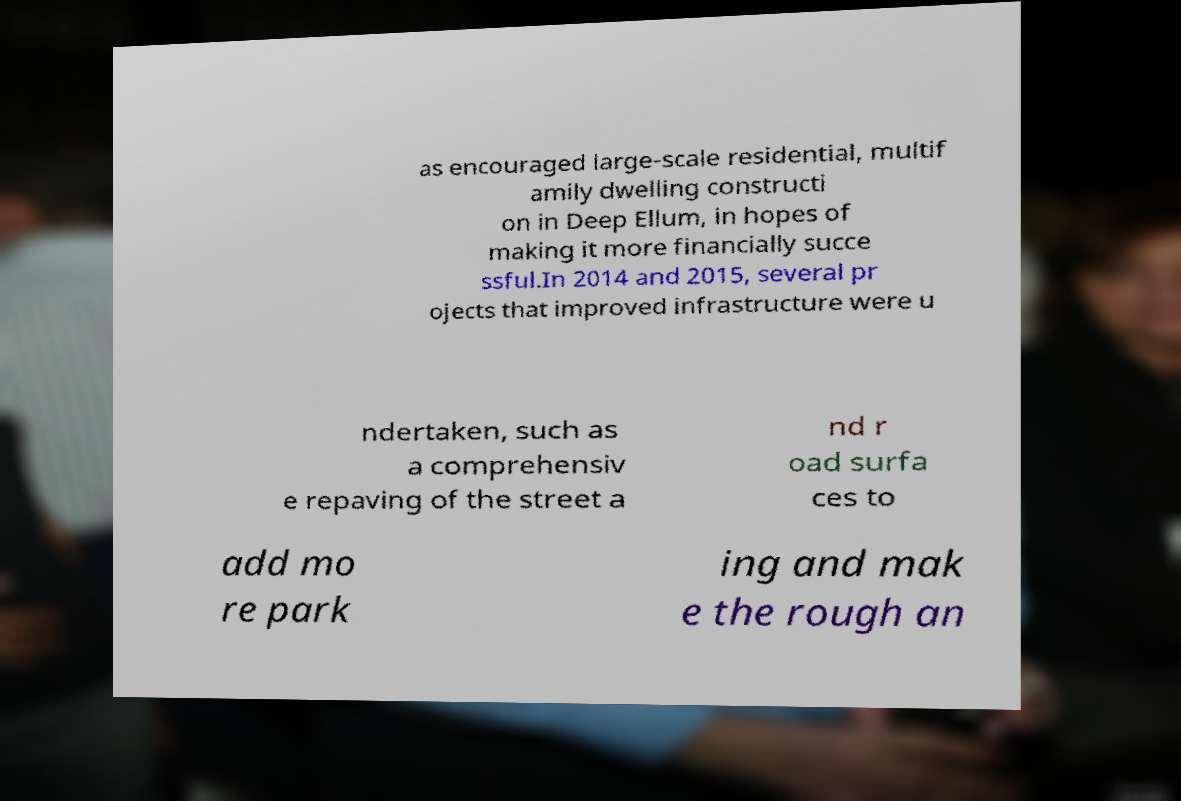Please read and relay the text visible in this image. What does it say? as encouraged large-scale residential, multif amily dwelling constructi on in Deep Ellum, in hopes of making it more financially succe ssful.In 2014 and 2015, several pr ojects that improved infrastructure were u ndertaken, such as a comprehensiv e repaving of the street a nd r oad surfa ces to add mo re park ing and mak e the rough an 